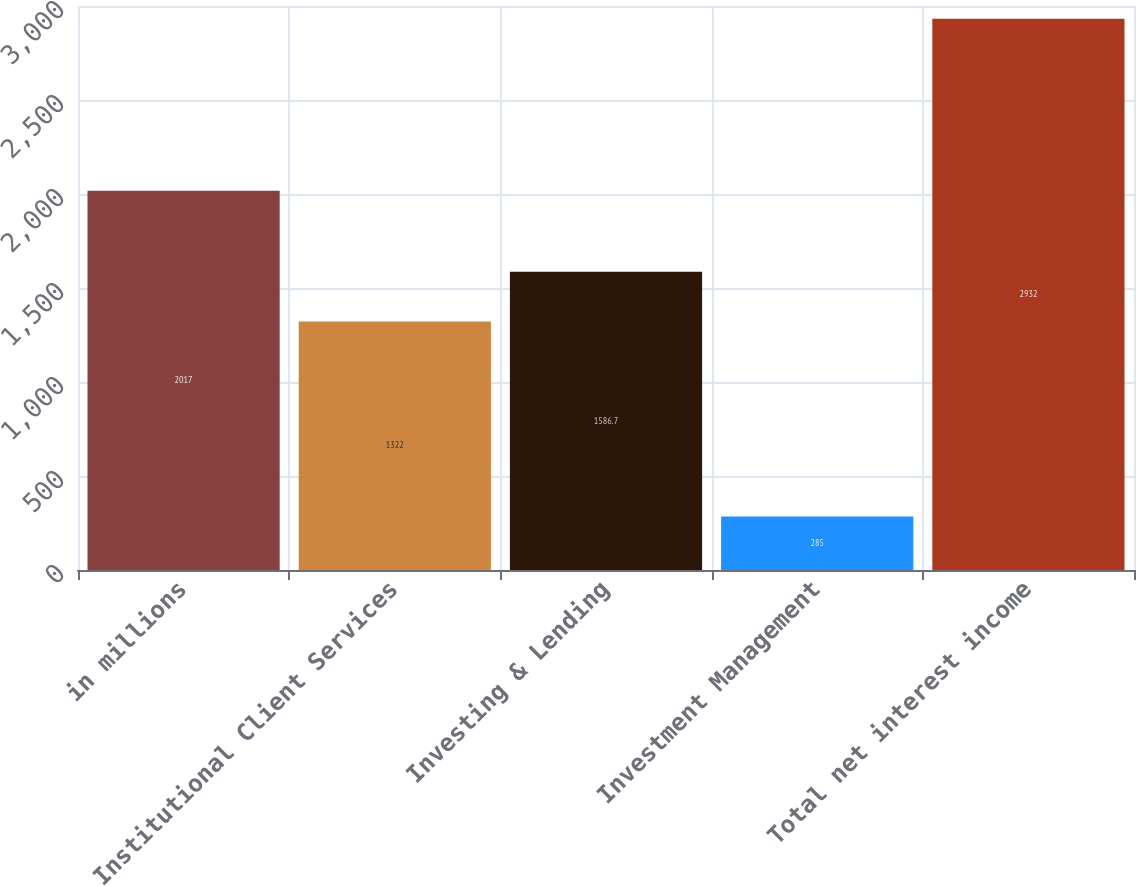<chart> <loc_0><loc_0><loc_500><loc_500><bar_chart><fcel>in millions<fcel>Institutional Client Services<fcel>Investing & Lending<fcel>Investment Management<fcel>Total net interest income<nl><fcel>2017<fcel>1322<fcel>1586.7<fcel>285<fcel>2932<nl></chart> 